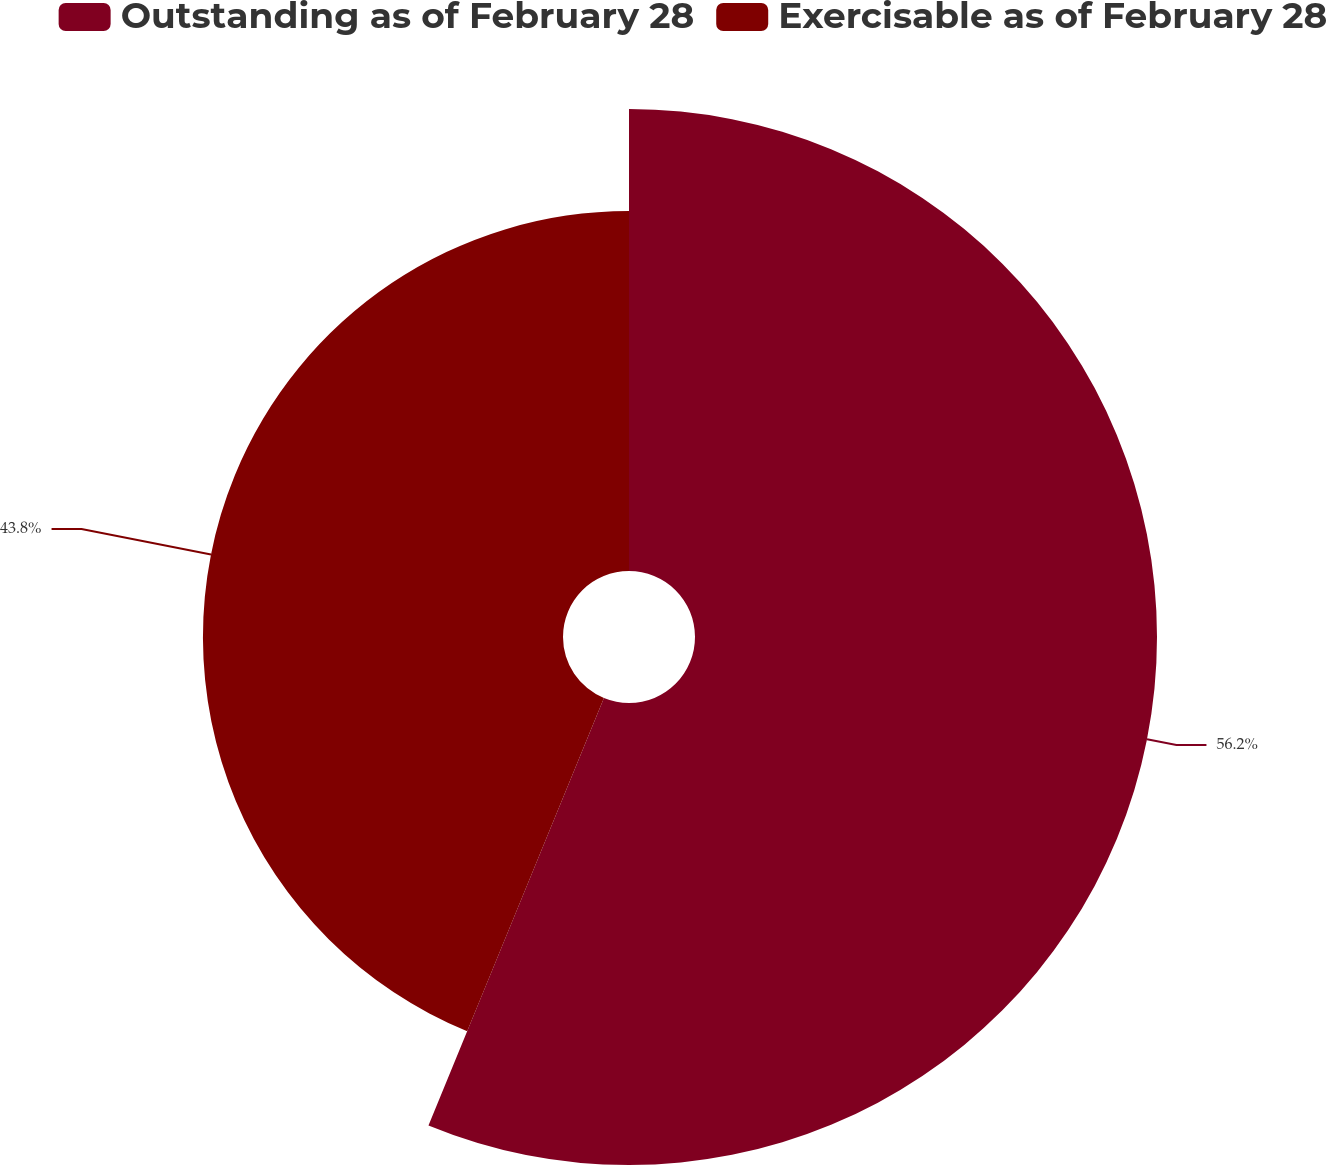<chart> <loc_0><loc_0><loc_500><loc_500><pie_chart><fcel>Outstanding as of February 28<fcel>Exercisable as of February 28<nl><fcel>56.2%<fcel>43.8%<nl></chart> 